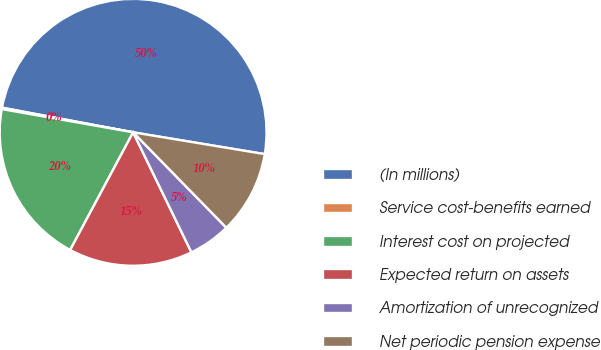Convert chart to OTSL. <chart><loc_0><loc_0><loc_500><loc_500><pie_chart><fcel>(In millions)<fcel>Service cost-benefits earned<fcel>Interest cost on projected<fcel>Expected return on assets<fcel>Amortization of unrecognized<fcel>Net periodic pension expense<nl><fcel>49.66%<fcel>0.17%<fcel>19.97%<fcel>15.02%<fcel>5.12%<fcel>10.07%<nl></chart> 